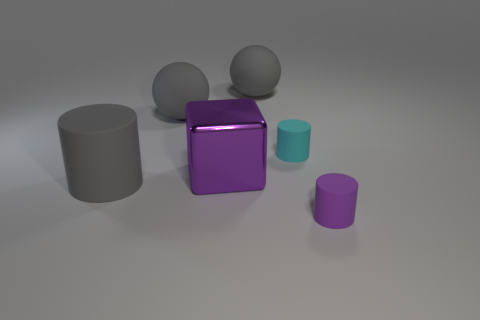What number of other things are there of the same color as the big block?
Provide a succinct answer. 1. What color is the cylinder that is to the right of the tiny matte thing that is behind the purple metal thing?
Provide a succinct answer. Purple. Are there any rubber things that have the same color as the metallic object?
Give a very brief answer. Yes. What number of rubber objects are small purple things or spheres?
Provide a succinct answer. 3. Are there any tiny spheres that have the same material as the big purple cube?
Make the answer very short. No. How many things are on the right side of the large gray cylinder and behind the purple cylinder?
Offer a terse response. 4. Is the number of big cylinders that are behind the metallic object less than the number of things that are in front of the purple cylinder?
Keep it short and to the point. No. Does the purple matte thing have the same shape as the big purple thing?
Give a very brief answer. No. What number of other objects are the same size as the purple shiny block?
Provide a succinct answer. 3. What number of objects are big gray rubber objects that are behind the tiny cyan rubber thing or tiny rubber things that are behind the metal object?
Your response must be concise. 3. 